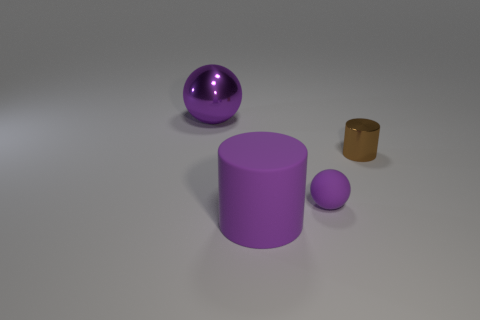Add 4 small blue shiny balls. How many objects exist? 8 Subtract all metal objects. Subtract all shiny spheres. How many objects are left? 1 Add 1 rubber balls. How many rubber balls are left? 2 Add 4 big purple objects. How many big purple objects exist? 6 Subtract 0 green cylinders. How many objects are left? 4 